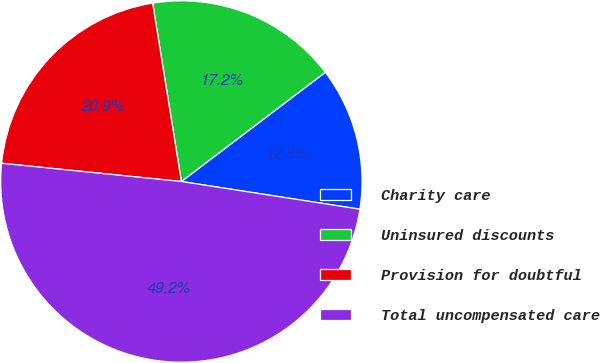<chart> <loc_0><loc_0><loc_500><loc_500><pie_chart><fcel>Charity care<fcel>Uninsured discounts<fcel>Provision for doubtful<fcel>Total uncompensated care<nl><fcel>12.78%<fcel>17.21%<fcel>20.85%<fcel>49.16%<nl></chart> 